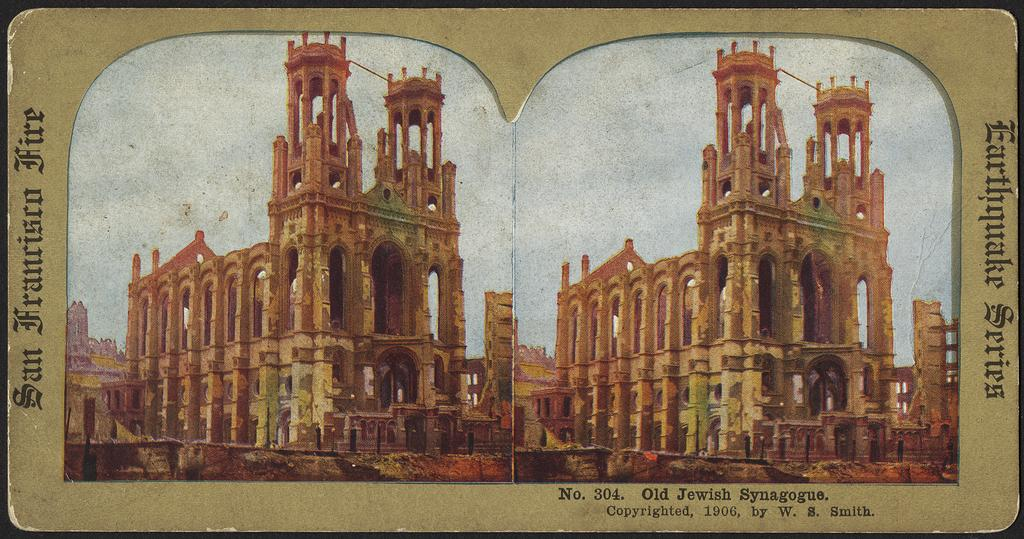How many buildings are visible in the image? There are two buildings in the image, one on the left side and one on the right side. What can be seen on the left side of the image besides the building? There are words written on the left side of the image. What can be seen on the right side of the image besides the building? There are words written on the right side of the image. Where are additional words located in the image? There are words written on the bottom of the image. Can you tell me how the judge is smiling in the image? There is no judge or smile present in the image; it only features two buildings and words. 